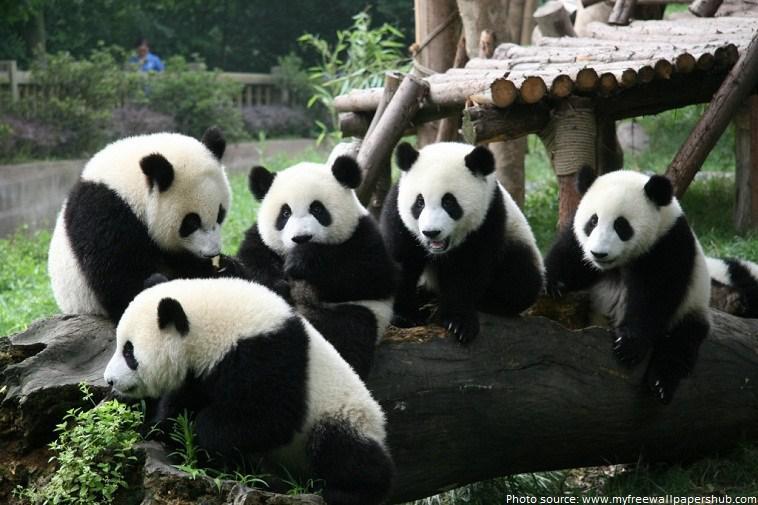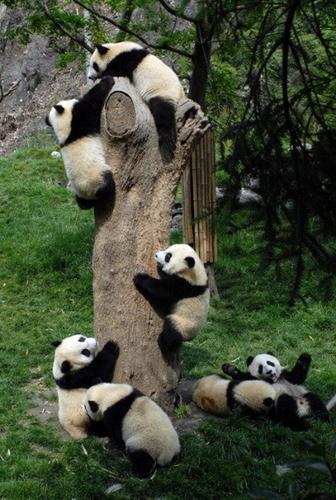The first image is the image on the left, the second image is the image on the right. Considering the images on both sides, is "There's no more than two pandas in the right image." valid? Answer yes or no. No. The first image is the image on the left, the second image is the image on the right. For the images shown, is this caption "An image includes at least four pandas posed in a horizontal row." true? Answer yes or no. Yes. 